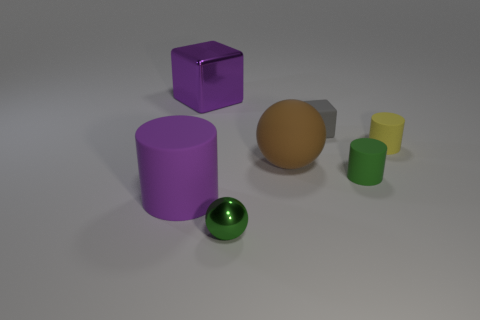Is the large sphere made of the same material as the purple cylinder? While the large sphere and the purple cylinder exhibit different colors and may reflect light slightly differently, from the image provided, it is not possible to accurately determine the materials solely based on visual inspection. However, based on their similar matte surfaces, one might speculate that they could be made from the same or similar types of material, although not necessarily the same exact substance. 